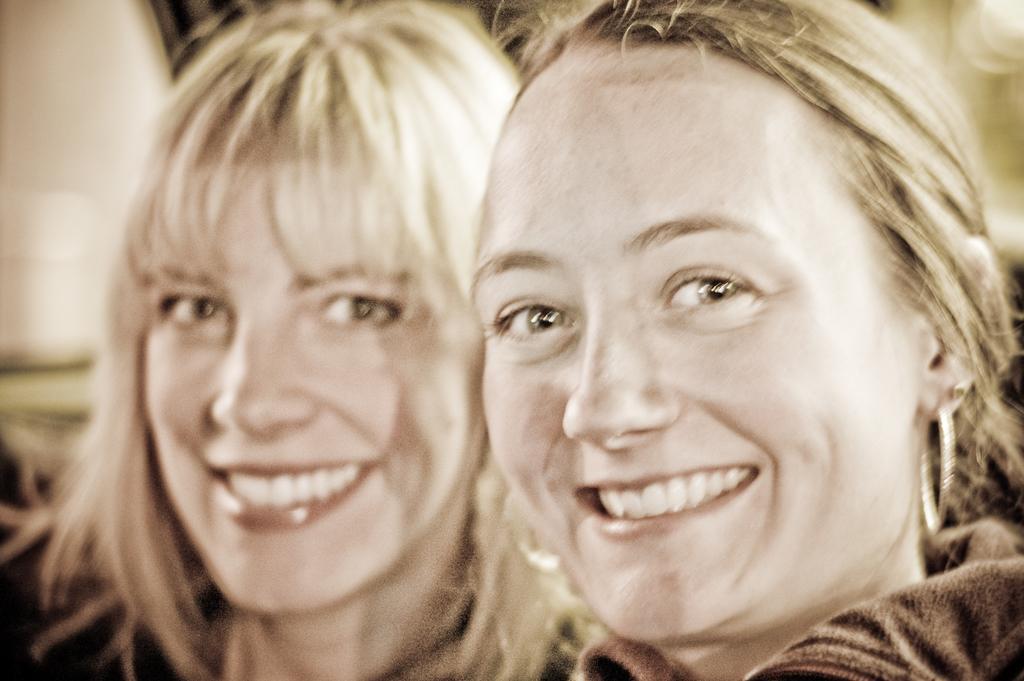Please provide a concise description of this image. In this image we can see two women with smiling faces, one white object on the top left side of the image and the background is blurred. 